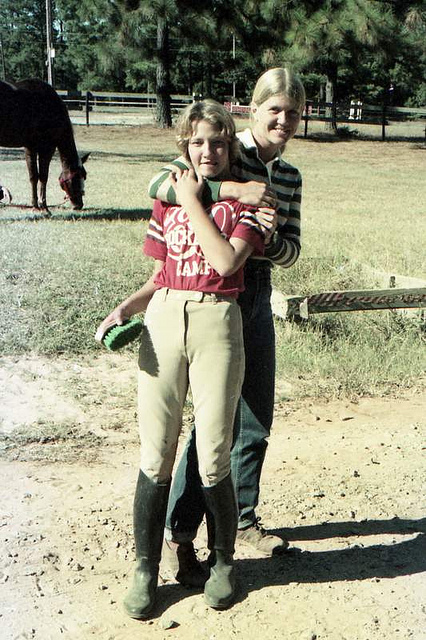<image>What is the horse's name in the background? It is unknown what the horse's name in the background is. What is the horse's name in the background? I am not aware of the horse's name in the background. 